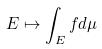<formula> <loc_0><loc_0><loc_500><loc_500>E \mapsto \int _ { E } f d \mu</formula> 